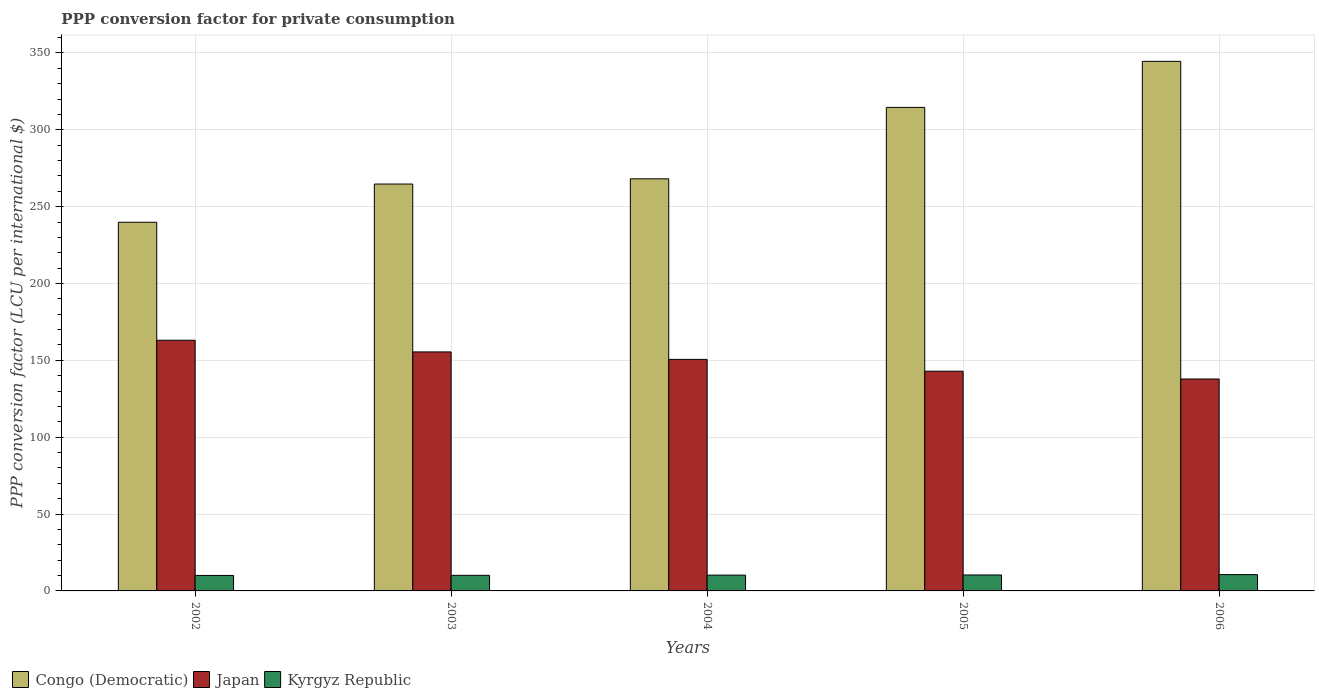Are the number of bars on each tick of the X-axis equal?
Give a very brief answer. Yes. How many bars are there on the 4th tick from the left?
Offer a terse response. 3. What is the PPP conversion factor for private consumption in Japan in 2003?
Make the answer very short. 155.48. Across all years, what is the maximum PPP conversion factor for private consumption in Congo (Democratic)?
Ensure brevity in your answer.  344.51. Across all years, what is the minimum PPP conversion factor for private consumption in Congo (Democratic)?
Your answer should be very brief. 239.83. In which year was the PPP conversion factor for private consumption in Kyrgyz Republic maximum?
Keep it short and to the point. 2006. In which year was the PPP conversion factor for private consumption in Congo (Democratic) minimum?
Make the answer very short. 2002. What is the total PPP conversion factor for private consumption in Japan in the graph?
Your answer should be compact. 749.99. What is the difference between the PPP conversion factor for private consumption in Congo (Democratic) in 2002 and that in 2005?
Your response must be concise. -74.74. What is the difference between the PPP conversion factor for private consumption in Congo (Democratic) in 2003 and the PPP conversion factor for private consumption in Kyrgyz Republic in 2002?
Make the answer very short. 254.62. What is the average PPP conversion factor for private consumption in Congo (Democratic) per year?
Your answer should be compact. 286.34. In the year 2004, what is the difference between the PPP conversion factor for private consumption in Japan and PPP conversion factor for private consumption in Kyrgyz Republic?
Make the answer very short. 140.35. What is the ratio of the PPP conversion factor for private consumption in Japan in 2003 to that in 2005?
Your answer should be very brief. 1.09. Is the difference between the PPP conversion factor for private consumption in Japan in 2002 and 2004 greater than the difference between the PPP conversion factor for private consumption in Kyrgyz Republic in 2002 and 2004?
Your answer should be very brief. Yes. What is the difference between the highest and the second highest PPP conversion factor for private consumption in Congo (Democratic)?
Ensure brevity in your answer.  29.95. What is the difference between the highest and the lowest PPP conversion factor for private consumption in Japan?
Offer a terse response. 25.21. Is the sum of the PPP conversion factor for private consumption in Kyrgyz Republic in 2005 and 2006 greater than the maximum PPP conversion factor for private consumption in Congo (Democratic) across all years?
Your answer should be very brief. No. What does the 3rd bar from the left in 2004 represents?
Ensure brevity in your answer.  Kyrgyz Republic. How many bars are there?
Give a very brief answer. 15. How many years are there in the graph?
Your response must be concise. 5. What is the difference between two consecutive major ticks on the Y-axis?
Offer a very short reply. 50. Are the values on the major ticks of Y-axis written in scientific E-notation?
Your answer should be very brief. No. Does the graph contain grids?
Give a very brief answer. Yes. What is the title of the graph?
Your response must be concise. PPP conversion factor for private consumption. What is the label or title of the Y-axis?
Your answer should be compact. PPP conversion factor (LCU per international $). What is the PPP conversion factor (LCU per international $) in Congo (Democratic) in 2002?
Offer a very short reply. 239.83. What is the PPP conversion factor (LCU per international $) in Japan in 2002?
Provide a succinct answer. 163.07. What is the PPP conversion factor (LCU per international $) in Kyrgyz Republic in 2002?
Provide a succinct answer. 10.07. What is the PPP conversion factor (LCU per international $) in Congo (Democratic) in 2003?
Your response must be concise. 264.69. What is the PPP conversion factor (LCU per international $) of Japan in 2003?
Your answer should be very brief. 155.48. What is the PPP conversion factor (LCU per international $) in Kyrgyz Republic in 2003?
Your response must be concise. 10.14. What is the PPP conversion factor (LCU per international $) of Congo (Democratic) in 2004?
Keep it short and to the point. 268.09. What is the PPP conversion factor (LCU per international $) in Japan in 2004?
Ensure brevity in your answer.  150.63. What is the PPP conversion factor (LCU per international $) of Kyrgyz Republic in 2004?
Provide a short and direct response. 10.28. What is the PPP conversion factor (LCU per international $) of Congo (Democratic) in 2005?
Provide a short and direct response. 314.56. What is the PPP conversion factor (LCU per international $) of Japan in 2005?
Your answer should be compact. 142.94. What is the PPP conversion factor (LCU per international $) of Kyrgyz Republic in 2005?
Your answer should be very brief. 10.37. What is the PPP conversion factor (LCU per international $) in Congo (Democratic) in 2006?
Give a very brief answer. 344.51. What is the PPP conversion factor (LCU per international $) of Japan in 2006?
Your response must be concise. 137.87. What is the PPP conversion factor (LCU per international $) of Kyrgyz Republic in 2006?
Your response must be concise. 10.61. Across all years, what is the maximum PPP conversion factor (LCU per international $) in Congo (Democratic)?
Your answer should be compact. 344.51. Across all years, what is the maximum PPP conversion factor (LCU per international $) of Japan?
Your response must be concise. 163.07. Across all years, what is the maximum PPP conversion factor (LCU per international $) of Kyrgyz Republic?
Ensure brevity in your answer.  10.61. Across all years, what is the minimum PPP conversion factor (LCU per international $) in Congo (Democratic)?
Your answer should be compact. 239.83. Across all years, what is the minimum PPP conversion factor (LCU per international $) in Japan?
Ensure brevity in your answer.  137.87. Across all years, what is the minimum PPP conversion factor (LCU per international $) of Kyrgyz Republic?
Offer a terse response. 10.07. What is the total PPP conversion factor (LCU per international $) of Congo (Democratic) in the graph?
Provide a succinct answer. 1431.68. What is the total PPP conversion factor (LCU per international $) in Japan in the graph?
Offer a terse response. 749.99. What is the total PPP conversion factor (LCU per international $) in Kyrgyz Republic in the graph?
Keep it short and to the point. 51.46. What is the difference between the PPP conversion factor (LCU per international $) of Congo (Democratic) in 2002 and that in 2003?
Offer a terse response. -24.87. What is the difference between the PPP conversion factor (LCU per international $) in Japan in 2002 and that in 2003?
Your response must be concise. 7.59. What is the difference between the PPP conversion factor (LCU per international $) in Kyrgyz Republic in 2002 and that in 2003?
Ensure brevity in your answer.  -0.07. What is the difference between the PPP conversion factor (LCU per international $) of Congo (Democratic) in 2002 and that in 2004?
Make the answer very short. -28.26. What is the difference between the PPP conversion factor (LCU per international $) of Japan in 2002 and that in 2004?
Your answer should be compact. 12.45. What is the difference between the PPP conversion factor (LCU per international $) in Kyrgyz Republic in 2002 and that in 2004?
Give a very brief answer. -0.21. What is the difference between the PPP conversion factor (LCU per international $) in Congo (Democratic) in 2002 and that in 2005?
Provide a short and direct response. -74.74. What is the difference between the PPP conversion factor (LCU per international $) in Japan in 2002 and that in 2005?
Offer a terse response. 20.14. What is the difference between the PPP conversion factor (LCU per international $) in Kyrgyz Republic in 2002 and that in 2005?
Keep it short and to the point. -0.31. What is the difference between the PPP conversion factor (LCU per international $) of Congo (Democratic) in 2002 and that in 2006?
Keep it short and to the point. -104.68. What is the difference between the PPP conversion factor (LCU per international $) in Japan in 2002 and that in 2006?
Your answer should be very brief. 25.21. What is the difference between the PPP conversion factor (LCU per international $) of Kyrgyz Republic in 2002 and that in 2006?
Provide a short and direct response. -0.54. What is the difference between the PPP conversion factor (LCU per international $) of Congo (Democratic) in 2003 and that in 2004?
Make the answer very short. -3.4. What is the difference between the PPP conversion factor (LCU per international $) of Japan in 2003 and that in 2004?
Ensure brevity in your answer.  4.86. What is the difference between the PPP conversion factor (LCU per international $) of Kyrgyz Republic in 2003 and that in 2004?
Offer a very short reply. -0.14. What is the difference between the PPP conversion factor (LCU per international $) of Congo (Democratic) in 2003 and that in 2005?
Make the answer very short. -49.87. What is the difference between the PPP conversion factor (LCU per international $) in Japan in 2003 and that in 2005?
Make the answer very short. 12.55. What is the difference between the PPP conversion factor (LCU per international $) of Kyrgyz Republic in 2003 and that in 2005?
Ensure brevity in your answer.  -0.24. What is the difference between the PPP conversion factor (LCU per international $) of Congo (Democratic) in 2003 and that in 2006?
Ensure brevity in your answer.  -79.82. What is the difference between the PPP conversion factor (LCU per international $) in Japan in 2003 and that in 2006?
Your answer should be very brief. 17.62. What is the difference between the PPP conversion factor (LCU per international $) of Kyrgyz Republic in 2003 and that in 2006?
Provide a succinct answer. -0.47. What is the difference between the PPP conversion factor (LCU per international $) of Congo (Democratic) in 2004 and that in 2005?
Give a very brief answer. -46.48. What is the difference between the PPP conversion factor (LCU per international $) in Japan in 2004 and that in 2005?
Provide a short and direct response. 7.69. What is the difference between the PPP conversion factor (LCU per international $) in Kyrgyz Republic in 2004 and that in 2005?
Your answer should be very brief. -0.1. What is the difference between the PPP conversion factor (LCU per international $) of Congo (Democratic) in 2004 and that in 2006?
Make the answer very short. -76.42. What is the difference between the PPP conversion factor (LCU per international $) of Japan in 2004 and that in 2006?
Make the answer very short. 12.76. What is the difference between the PPP conversion factor (LCU per international $) of Kyrgyz Republic in 2004 and that in 2006?
Offer a terse response. -0.33. What is the difference between the PPP conversion factor (LCU per international $) of Congo (Democratic) in 2005 and that in 2006?
Make the answer very short. -29.95. What is the difference between the PPP conversion factor (LCU per international $) in Japan in 2005 and that in 2006?
Offer a very short reply. 5.07. What is the difference between the PPP conversion factor (LCU per international $) in Kyrgyz Republic in 2005 and that in 2006?
Provide a succinct answer. -0.23. What is the difference between the PPP conversion factor (LCU per international $) in Congo (Democratic) in 2002 and the PPP conversion factor (LCU per international $) in Japan in 2003?
Offer a very short reply. 84.34. What is the difference between the PPP conversion factor (LCU per international $) in Congo (Democratic) in 2002 and the PPP conversion factor (LCU per international $) in Kyrgyz Republic in 2003?
Offer a very short reply. 229.69. What is the difference between the PPP conversion factor (LCU per international $) of Japan in 2002 and the PPP conversion factor (LCU per international $) of Kyrgyz Republic in 2003?
Ensure brevity in your answer.  152.94. What is the difference between the PPP conversion factor (LCU per international $) in Congo (Democratic) in 2002 and the PPP conversion factor (LCU per international $) in Japan in 2004?
Your response must be concise. 89.2. What is the difference between the PPP conversion factor (LCU per international $) of Congo (Democratic) in 2002 and the PPP conversion factor (LCU per international $) of Kyrgyz Republic in 2004?
Make the answer very short. 229.55. What is the difference between the PPP conversion factor (LCU per international $) of Japan in 2002 and the PPP conversion factor (LCU per international $) of Kyrgyz Republic in 2004?
Make the answer very short. 152.8. What is the difference between the PPP conversion factor (LCU per international $) of Congo (Democratic) in 2002 and the PPP conversion factor (LCU per international $) of Japan in 2005?
Your answer should be compact. 96.89. What is the difference between the PPP conversion factor (LCU per international $) of Congo (Democratic) in 2002 and the PPP conversion factor (LCU per international $) of Kyrgyz Republic in 2005?
Your answer should be very brief. 229.45. What is the difference between the PPP conversion factor (LCU per international $) of Japan in 2002 and the PPP conversion factor (LCU per international $) of Kyrgyz Republic in 2005?
Give a very brief answer. 152.7. What is the difference between the PPP conversion factor (LCU per international $) in Congo (Democratic) in 2002 and the PPP conversion factor (LCU per international $) in Japan in 2006?
Offer a terse response. 101.96. What is the difference between the PPP conversion factor (LCU per international $) in Congo (Democratic) in 2002 and the PPP conversion factor (LCU per international $) in Kyrgyz Republic in 2006?
Give a very brief answer. 229.22. What is the difference between the PPP conversion factor (LCU per international $) of Japan in 2002 and the PPP conversion factor (LCU per international $) of Kyrgyz Republic in 2006?
Offer a terse response. 152.47. What is the difference between the PPP conversion factor (LCU per international $) in Congo (Democratic) in 2003 and the PPP conversion factor (LCU per international $) in Japan in 2004?
Make the answer very short. 114.06. What is the difference between the PPP conversion factor (LCU per international $) in Congo (Democratic) in 2003 and the PPP conversion factor (LCU per international $) in Kyrgyz Republic in 2004?
Your answer should be very brief. 254.41. What is the difference between the PPP conversion factor (LCU per international $) of Japan in 2003 and the PPP conversion factor (LCU per international $) of Kyrgyz Republic in 2004?
Your response must be concise. 145.21. What is the difference between the PPP conversion factor (LCU per international $) of Congo (Democratic) in 2003 and the PPP conversion factor (LCU per international $) of Japan in 2005?
Ensure brevity in your answer.  121.76. What is the difference between the PPP conversion factor (LCU per international $) of Congo (Democratic) in 2003 and the PPP conversion factor (LCU per international $) of Kyrgyz Republic in 2005?
Give a very brief answer. 254.32. What is the difference between the PPP conversion factor (LCU per international $) of Japan in 2003 and the PPP conversion factor (LCU per international $) of Kyrgyz Republic in 2005?
Ensure brevity in your answer.  145.11. What is the difference between the PPP conversion factor (LCU per international $) of Congo (Democratic) in 2003 and the PPP conversion factor (LCU per international $) of Japan in 2006?
Your answer should be compact. 126.83. What is the difference between the PPP conversion factor (LCU per international $) in Congo (Democratic) in 2003 and the PPP conversion factor (LCU per international $) in Kyrgyz Republic in 2006?
Ensure brevity in your answer.  254.08. What is the difference between the PPP conversion factor (LCU per international $) of Japan in 2003 and the PPP conversion factor (LCU per international $) of Kyrgyz Republic in 2006?
Provide a succinct answer. 144.88. What is the difference between the PPP conversion factor (LCU per international $) of Congo (Democratic) in 2004 and the PPP conversion factor (LCU per international $) of Japan in 2005?
Give a very brief answer. 125.15. What is the difference between the PPP conversion factor (LCU per international $) in Congo (Democratic) in 2004 and the PPP conversion factor (LCU per international $) in Kyrgyz Republic in 2005?
Offer a terse response. 257.71. What is the difference between the PPP conversion factor (LCU per international $) in Japan in 2004 and the PPP conversion factor (LCU per international $) in Kyrgyz Republic in 2005?
Offer a terse response. 140.25. What is the difference between the PPP conversion factor (LCU per international $) in Congo (Democratic) in 2004 and the PPP conversion factor (LCU per international $) in Japan in 2006?
Ensure brevity in your answer.  130.22. What is the difference between the PPP conversion factor (LCU per international $) in Congo (Democratic) in 2004 and the PPP conversion factor (LCU per international $) in Kyrgyz Republic in 2006?
Make the answer very short. 257.48. What is the difference between the PPP conversion factor (LCU per international $) of Japan in 2004 and the PPP conversion factor (LCU per international $) of Kyrgyz Republic in 2006?
Make the answer very short. 140.02. What is the difference between the PPP conversion factor (LCU per international $) of Congo (Democratic) in 2005 and the PPP conversion factor (LCU per international $) of Japan in 2006?
Make the answer very short. 176.7. What is the difference between the PPP conversion factor (LCU per international $) in Congo (Democratic) in 2005 and the PPP conversion factor (LCU per international $) in Kyrgyz Republic in 2006?
Make the answer very short. 303.95. What is the difference between the PPP conversion factor (LCU per international $) of Japan in 2005 and the PPP conversion factor (LCU per international $) of Kyrgyz Republic in 2006?
Give a very brief answer. 132.33. What is the average PPP conversion factor (LCU per international $) of Congo (Democratic) per year?
Ensure brevity in your answer.  286.34. What is the average PPP conversion factor (LCU per international $) of Japan per year?
Give a very brief answer. 150. What is the average PPP conversion factor (LCU per international $) in Kyrgyz Republic per year?
Offer a terse response. 10.29. In the year 2002, what is the difference between the PPP conversion factor (LCU per international $) of Congo (Democratic) and PPP conversion factor (LCU per international $) of Japan?
Make the answer very short. 76.75. In the year 2002, what is the difference between the PPP conversion factor (LCU per international $) in Congo (Democratic) and PPP conversion factor (LCU per international $) in Kyrgyz Republic?
Offer a terse response. 229.76. In the year 2002, what is the difference between the PPP conversion factor (LCU per international $) in Japan and PPP conversion factor (LCU per international $) in Kyrgyz Republic?
Provide a short and direct response. 153.01. In the year 2003, what is the difference between the PPP conversion factor (LCU per international $) of Congo (Democratic) and PPP conversion factor (LCU per international $) of Japan?
Offer a very short reply. 109.21. In the year 2003, what is the difference between the PPP conversion factor (LCU per international $) in Congo (Democratic) and PPP conversion factor (LCU per international $) in Kyrgyz Republic?
Ensure brevity in your answer.  254.56. In the year 2003, what is the difference between the PPP conversion factor (LCU per international $) of Japan and PPP conversion factor (LCU per international $) of Kyrgyz Republic?
Ensure brevity in your answer.  145.35. In the year 2004, what is the difference between the PPP conversion factor (LCU per international $) in Congo (Democratic) and PPP conversion factor (LCU per international $) in Japan?
Offer a terse response. 117.46. In the year 2004, what is the difference between the PPP conversion factor (LCU per international $) in Congo (Democratic) and PPP conversion factor (LCU per international $) in Kyrgyz Republic?
Your answer should be very brief. 257.81. In the year 2004, what is the difference between the PPP conversion factor (LCU per international $) in Japan and PPP conversion factor (LCU per international $) in Kyrgyz Republic?
Your response must be concise. 140.35. In the year 2005, what is the difference between the PPP conversion factor (LCU per international $) in Congo (Democratic) and PPP conversion factor (LCU per international $) in Japan?
Your answer should be compact. 171.63. In the year 2005, what is the difference between the PPP conversion factor (LCU per international $) in Congo (Democratic) and PPP conversion factor (LCU per international $) in Kyrgyz Republic?
Ensure brevity in your answer.  304.19. In the year 2005, what is the difference between the PPP conversion factor (LCU per international $) of Japan and PPP conversion factor (LCU per international $) of Kyrgyz Republic?
Offer a very short reply. 132.56. In the year 2006, what is the difference between the PPP conversion factor (LCU per international $) of Congo (Democratic) and PPP conversion factor (LCU per international $) of Japan?
Your response must be concise. 206.64. In the year 2006, what is the difference between the PPP conversion factor (LCU per international $) in Congo (Democratic) and PPP conversion factor (LCU per international $) in Kyrgyz Republic?
Your answer should be compact. 333.9. In the year 2006, what is the difference between the PPP conversion factor (LCU per international $) of Japan and PPP conversion factor (LCU per international $) of Kyrgyz Republic?
Offer a terse response. 127.26. What is the ratio of the PPP conversion factor (LCU per international $) in Congo (Democratic) in 2002 to that in 2003?
Ensure brevity in your answer.  0.91. What is the ratio of the PPP conversion factor (LCU per international $) in Japan in 2002 to that in 2003?
Ensure brevity in your answer.  1.05. What is the ratio of the PPP conversion factor (LCU per international $) in Kyrgyz Republic in 2002 to that in 2003?
Make the answer very short. 0.99. What is the ratio of the PPP conversion factor (LCU per international $) of Congo (Democratic) in 2002 to that in 2004?
Provide a succinct answer. 0.89. What is the ratio of the PPP conversion factor (LCU per international $) in Japan in 2002 to that in 2004?
Make the answer very short. 1.08. What is the ratio of the PPP conversion factor (LCU per international $) in Kyrgyz Republic in 2002 to that in 2004?
Your response must be concise. 0.98. What is the ratio of the PPP conversion factor (LCU per international $) in Congo (Democratic) in 2002 to that in 2005?
Provide a short and direct response. 0.76. What is the ratio of the PPP conversion factor (LCU per international $) in Japan in 2002 to that in 2005?
Make the answer very short. 1.14. What is the ratio of the PPP conversion factor (LCU per international $) in Kyrgyz Republic in 2002 to that in 2005?
Provide a succinct answer. 0.97. What is the ratio of the PPP conversion factor (LCU per international $) of Congo (Democratic) in 2002 to that in 2006?
Give a very brief answer. 0.7. What is the ratio of the PPP conversion factor (LCU per international $) in Japan in 2002 to that in 2006?
Keep it short and to the point. 1.18. What is the ratio of the PPP conversion factor (LCU per international $) of Kyrgyz Republic in 2002 to that in 2006?
Offer a very short reply. 0.95. What is the ratio of the PPP conversion factor (LCU per international $) in Congo (Democratic) in 2003 to that in 2004?
Your answer should be very brief. 0.99. What is the ratio of the PPP conversion factor (LCU per international $) of Japan in 2003 to that in 2004?
Your response must be concise. 1.03. What is the ratio of the PPP conversion factor (LCU per international $) of Kyrgyz Republic in 2003 to that in 2004?
Make the answer very short. 0.99. What is the ratio of the PPP conversion factor (LCU per international $) of Congo (Democratic) in 2003 to that in 2005?
Provide a short and direct response. 0.84. What is the ratio of the PPP conversion factor (LCU per international $) of Japan in 2003 to that in 2005?
Your answer should be compact. 1.09. What is the ratio of the PPP conversion factor (LCU per international $) in Kyrgyz Republic in 2003 to that in 2005?
Provide a succinct answer. 0.98. What is the ratio of the PPP conversion factor (LCU per international $) in Congo (Democratic) in 2003 to that in 2006?
Ensure brevity in your answer.  0.77. What is the ratio of the PPP conversion factor (LCU per international $) of Japan in 2003 to that in 2006?
Ensure brevity in your answer.  1.13. What is the ratio of the PPP conversion factor (LCU per international $) in Kyrgyz Republic in 2003 to that in 2006?
Your answer should be compact. 0.96. What is the ratio of the PPP conversion factor (LCU per international $) in Congo (Democratic) in 2004 to that in 2005?
Provide a succinct answer. 0.85. What is the ratio of the PPP conversion factor (LCU per international $) of Japan in 2004 to that in 2005?
Offer a terse response. 1.05. What is the ratio of the PPP conversion factor (LCU per international $) in Congo (Democratic) in 2004 to that in 2006?
Provide a succinct answer. 0.78. What is the ratio of the PPP conversion factor (LCU per international $) in Japan in 2004 to that in 2006?
Your answer should be very brief. 1.09. What is the ratio of the PPP conversion factor (LCU per international $) of Kyrgyz Republic in 2004 to that in 2006?
Your answer should be very brief. 0.97. What is the ratio of the PPP conversion factor (LCU per international $) in Congo (Democratic) in 2005 to that in 2006?
Provide a short and direct response. 0.91. What is the ratio of the PPP conversion factor (LCU per international $) of Japan in 2005 to that in 2006?
Ensure brevity in your answer.  1.04. What is the ratio of the PPP conversion factor (LCU per international $) of Kyrgyz Republic in 2005 to that in 2006?
Offer a terse response. 0.98. What is the difference between the highest and the second highest PPP conversion factor (LCU per international $) of Congo (Democratic)?
Provide a succinct answer. 29.95. What is the difference between the highest and the second highest PPP conversion factor (LCU per international $) of Japan?
Offer a terse response. 7.59. What is the difference between the highest and the second highest PPP conversion factor (LCU per international $) in Kyrgyz Republic?
Ensure brevity in your answer.  0.23. What is the difference between the highest and the lowest PPP conversion factor (LCU per international $) of Congo (Democratic)?
Keep it short and to the point. 104.68. What is the difference between the highest and the lowest PPP conversion factor (LCU per international $) in Japan?
Your response must be concise. 25.21. What is the difference between the highest and the lowest PPP conversion factor (LCU per international $) of Kyrgyz Republic?
Ensure brevity in your answer.  0.54. 